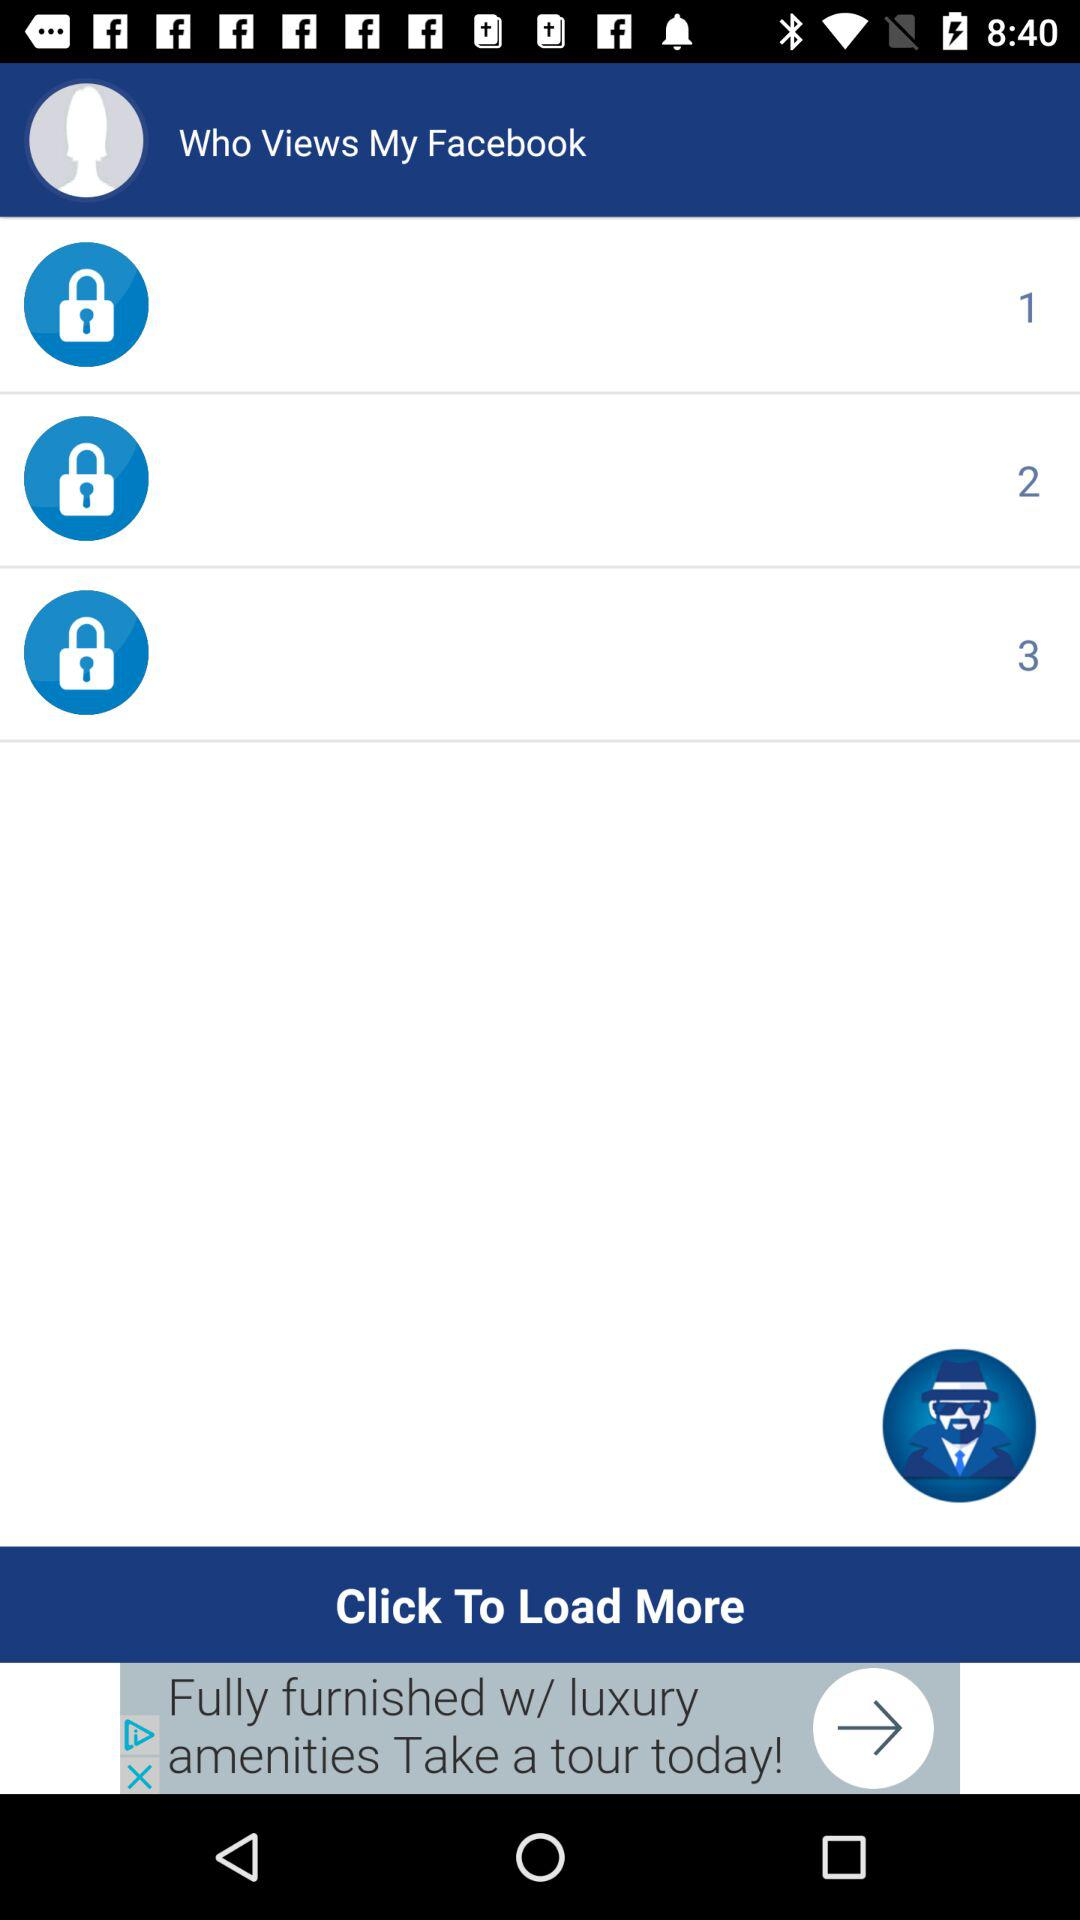How many people have viewed my Facebook?
Answer the question using a single word or phrase. 3 